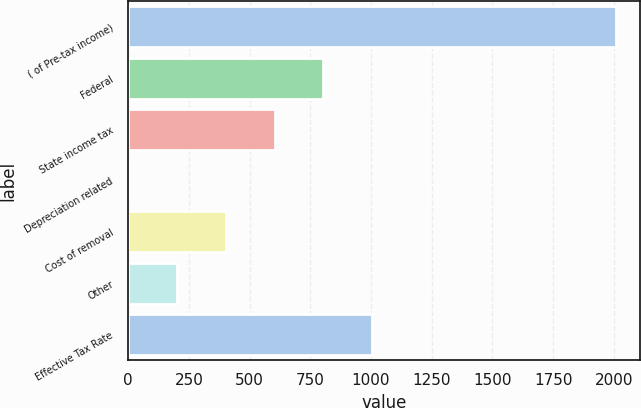Convert chart. <chart><loc_0><loc_0><loc_500><loc_500><bar_chart><fcel>( of Pre-tax income)<fcel>Federal<fcel>State income tax<fcel>Depreciation related<fcel>Cost of removal<fcel>Other<fcel>Effective Tax Rate<nl><fcel>2008<fcel>803.8<fcel>603.1<fcel>1<fcel>402.4<fcel>201.7<fcel>1004.5<nl></chart> 